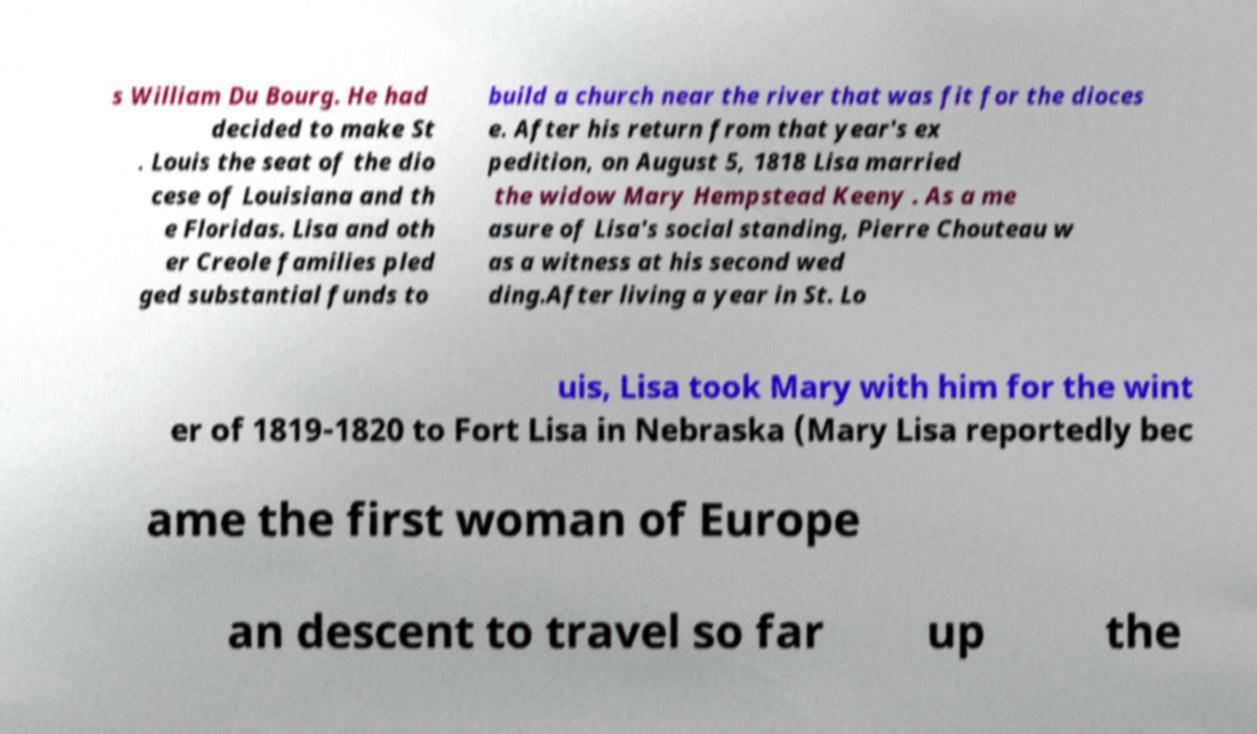Please read and relay the text visible in this image. What does it say? s William Du Bourg. He had decided to make St . Louis the seat of the dio cese of Louisiana and th e Floridas. Lisa and oth er Creole families pled ged substantial funds to build a church near the river that was fit for the dioces e. After his return from that year's ex pedition, on August 5, 1818 Lisa married the widow Mary Hempstead Keeny . As a me asure of Lisa's social standing, Pierre Chouteau w as a witness at his second wed ding.After living a year in St. Lo uis, Lisa took Mary with him for the wint er of 1819-1820 to Fort Lisa in Nebraska (Mary Lisa reportedly bec ame the first woman of Europe an descent to travel so far up the 